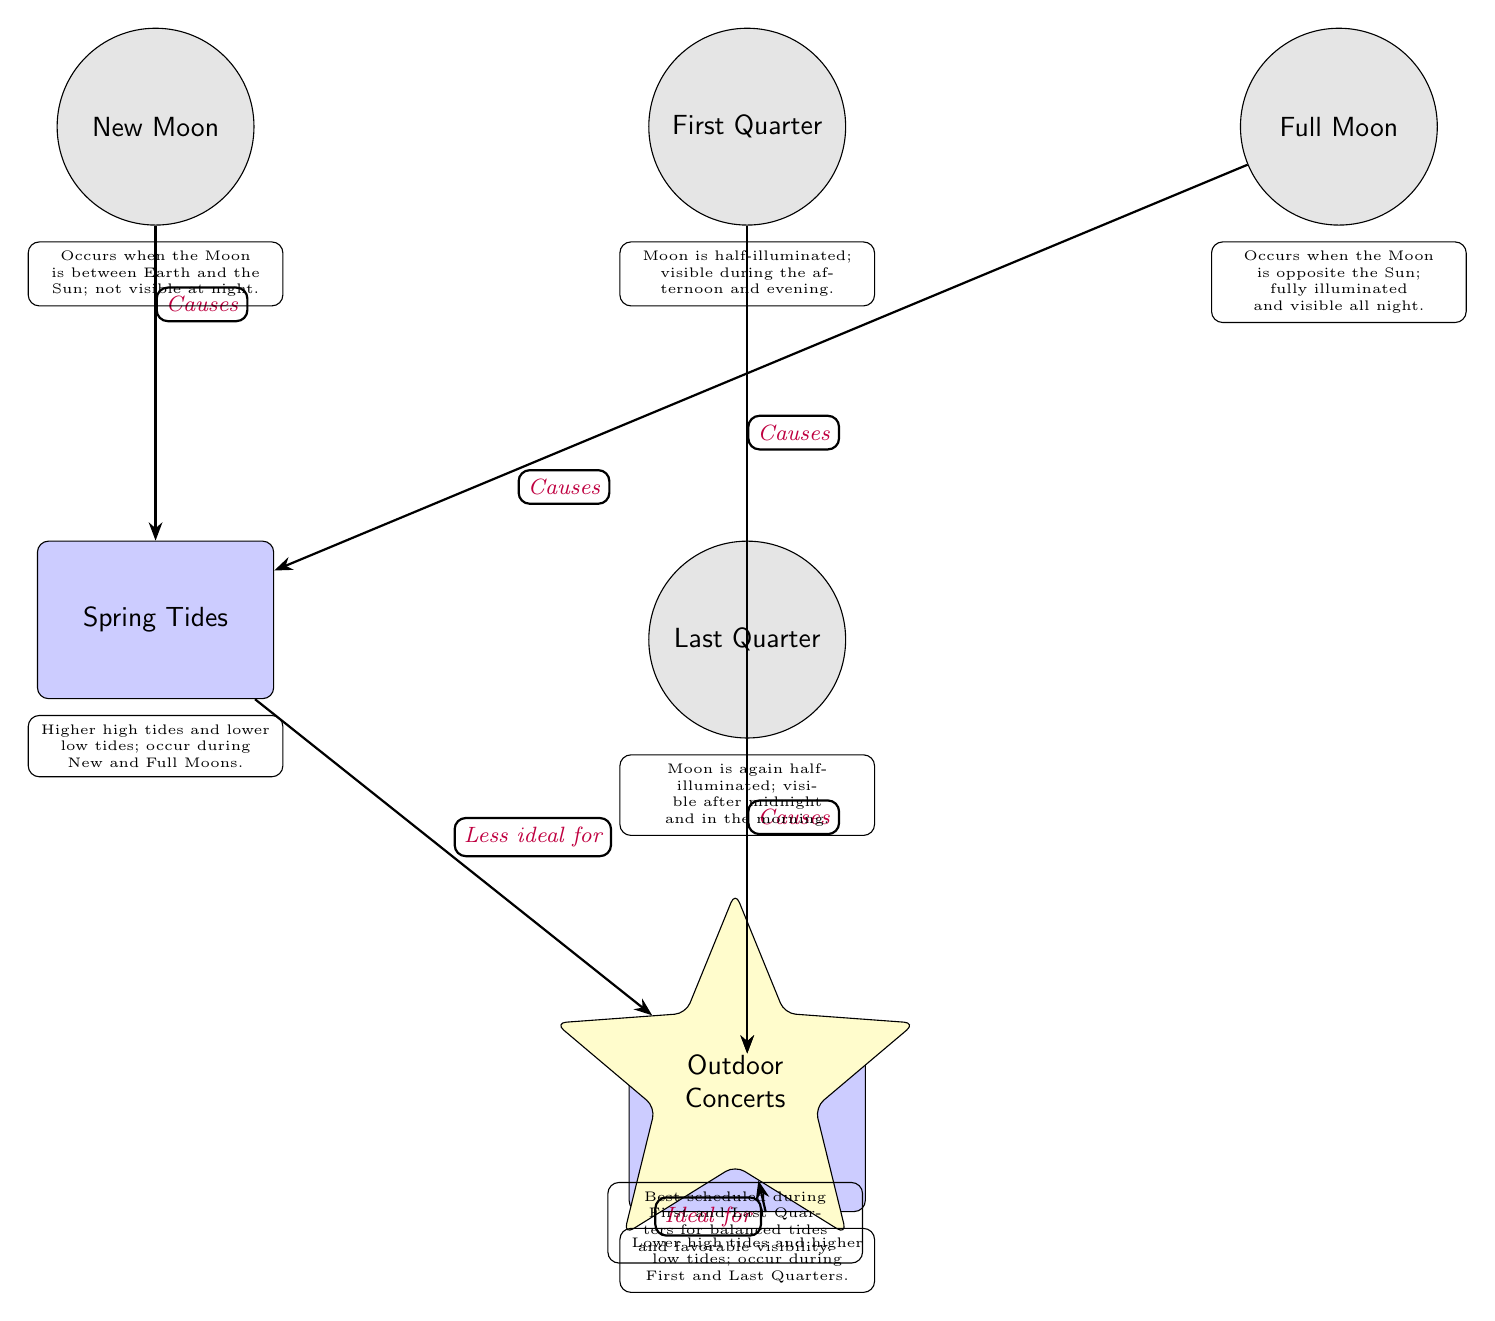What moon phase causes Spring Tides? According to the diagram, both New Moon and Full Moon phases cause Spring Tides. The connection between New Moon and Spring Tides is indicated with an arrow referencing "Causes." A similar arrow from Full Moon to Spring Tides shows the same relationship.
Answer: New Moon and Full Moon What type of tides occur during the Last Quarter? The diagram shows that the Last Quarter moon phase leads to Neap Tides, with an arrow labeled "Causes" pointing from Last Quarter to Neap Tides.
Answer: Neap Tides Which moon phases are ideal for scheduling outdoor concerts? The diagram indicates that outdoor concerts are best scheduled during First and Last Quarters. This is shown with the phrase "Best scheduled during" leading from Neap Tides (after First Quarter) and Last Quarter to the Outdoor Concerts node.
Answer: First and Last Quarters What is the effect of Spring Tides on outdoor concerts? The diagram specifies that Spring Tides are "Less ideal for" outdoor concerts as indicated by the arrow pointing from Spring Tides to the Outdoor Concerts node, which suggests scheduling challenges during this tide type.
Answer: Less ideal for How many nodes represent the phases of the moon in the diagram? The diagram contains four nodes representing the phases of the moon: New Moon, First Quarter, Full Moon, and Last Quarter. Counting these nodes gives the total number of moon phase representations.
Answer: Four Which tide is indicated as ideal for scheduling outdoor concerts? The diagram indicates that Neap Tides are "Ideal for" outdoor concerts, explicitly stating this connection with an arrow pointing from Neap Tides to the Outdoor Concerts node.
Answer: Neap Tides What is the visual representation of outdoor concerts in the diagram? According to the diagram, outdoor concerts are represented as a star shape with five points, colored yellow, showing its distinction from the other nodes.
Answer: Star (yellow) Which moon phase is half-illuminated and visible in the afternoon? The First Quarter phase of the moon is half-illuminated and is stated to be visible during the afternoon and evening, as described in the notes associated with that node.
Answer: First Quarter 